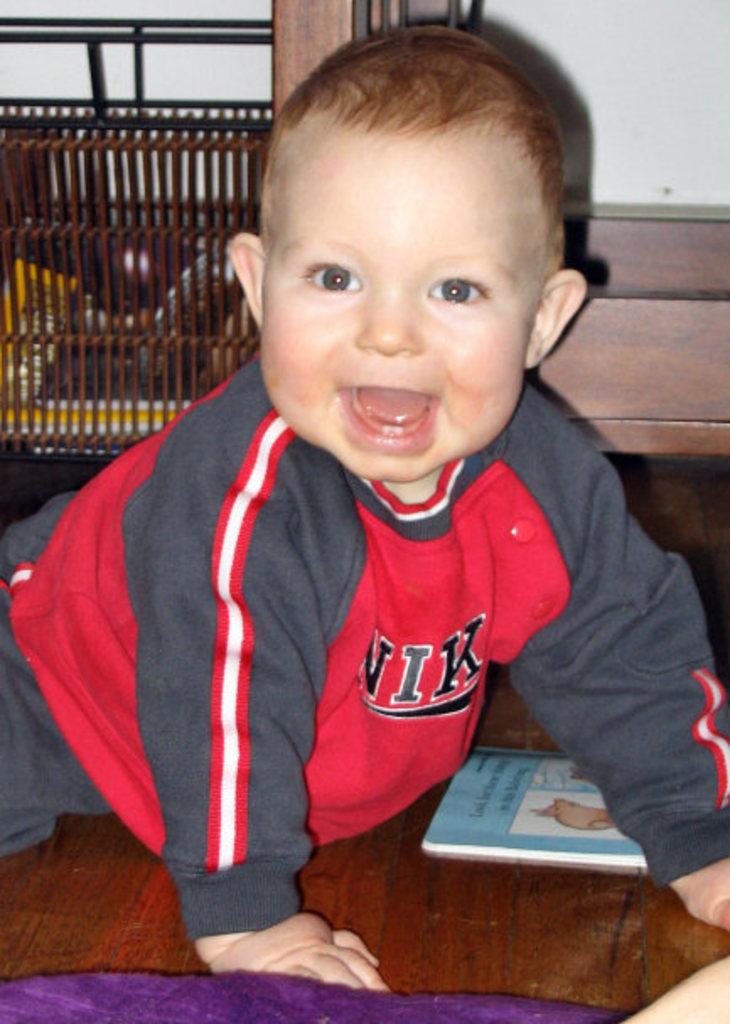What brand of shirt is the baby wearing?
Ensure brevity in your answer.  Nike. What is the last visible letter on the kid's shirt?
Provide a succinct answer. K. 